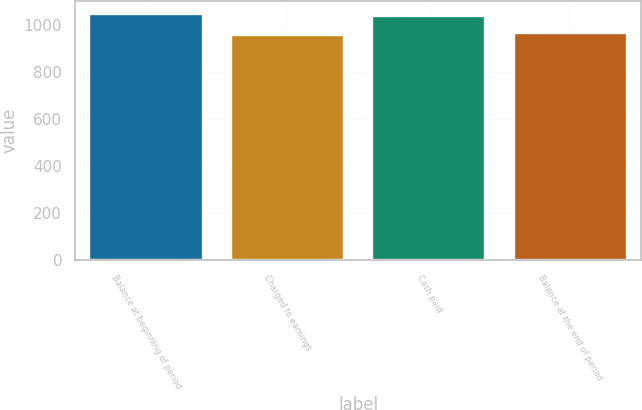<chart> <loc_0><loc_0><loc_500><loc_500><bar_chart><fcel>Balance at beginning of period<fcel>Charged to earnings<fcel>Cash paid<fcel>Balance at the end of period<nl><fcel>1049.8<fcel>960<fcel>1041<fcel>968.8<nl></chart> 